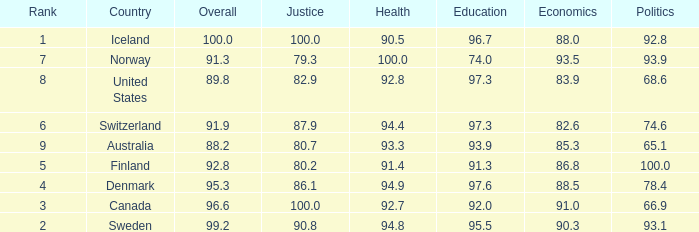What's the economics score with education being 92.0 91.0. 